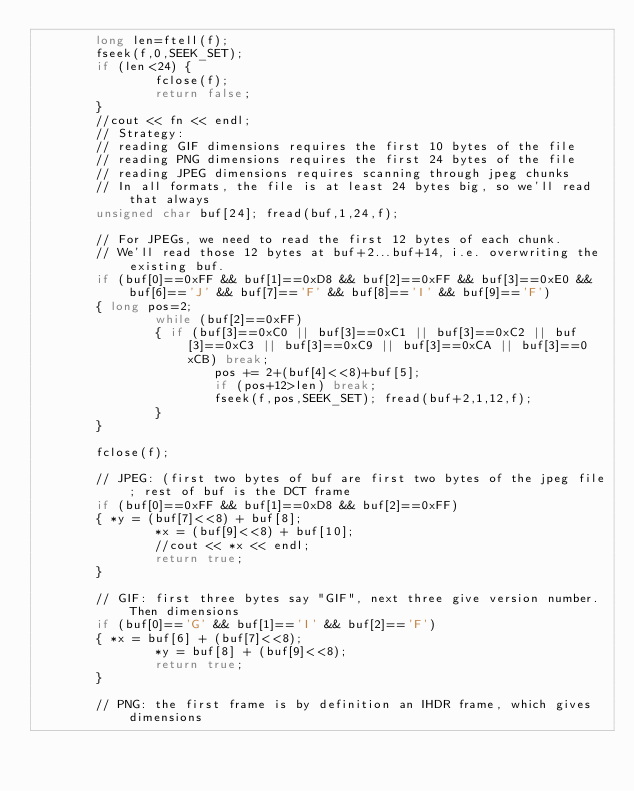<code> <loc_0><loc_0><loc_500><loc_500><_C++_>				long len=ftell(f);
				fseek(f,0,SEEK_SET);
				if (len<24) {
								fclose(f);
								return false;
				}
				//cout << fn << endl;
				// Strategy:
				// reading GIF dimensions requires the first 10 bytes of the file
				// reading PNG dimensions requires the first 24 bytes of the file
				// reading JPEG dimensions requires scanning through jpeg chunks
				// In all formats, the file is at least 24 bytes big, so we'll read that always
				unsigned char buf[24]; fread(buf,1,24,f);

				// For JPEGs, we need to read the first 12 bytes of each chunk.
				// We'll read those 12 bytes at buf+2...buf+14, i.e. overwriting the existing buf.
				if (buf[0]==0xFF && buf[1]==0xD8 && buf[2]==0xFF && buf[3]==0xE0 && buf[6]=='J' && buf[7]=='F' && buf[8]=='I' && buf[9]=='F')
				{ long pos=2;
								while (buf[2]==0xFF)
								{ if (buf[3]==0xC0 || buf[3]==0xC1 || buf[3]==0xC2 || buf[3]==0xC3 || buf[3]==0xC9 || buf[3]==0xCA || buf[3]==0xCB) break;
												pos += 2+(buf[4]<<8)+buf[5];
												if (pos+12>len) break;
												fseek(f,pos,SEEK_SET); fread(buf+2,1,12,f);
								}
				}

				fclose(f);

				// JPEG: (first two bytes of buf are first two bytes of the jpeg file; rest of buf is the DCT frame
				if (buf[0]==0xFF && buf[1]==0xD8 && buf[2]==0xFF)
				{ *y = (buf[7]<<8) + buf[8];
								*x = (buf[9]<<8) + buf[10];
								//cout << *x << endl;
								return true;
				}

				// GIF: first three bytes say "GIF", next three give version number. Then dimensions
				if (buf[0]=='G' && buf[1]=='I' && buf[2]=='F')
				{ *x = buf[6] + (buf[7]<<8);
								*y = buf[8] + (buf[9]<<8);
								return true;
				}

				// PNG: the first frame is by definition an IHDR frame, which gives dimensions</code> 